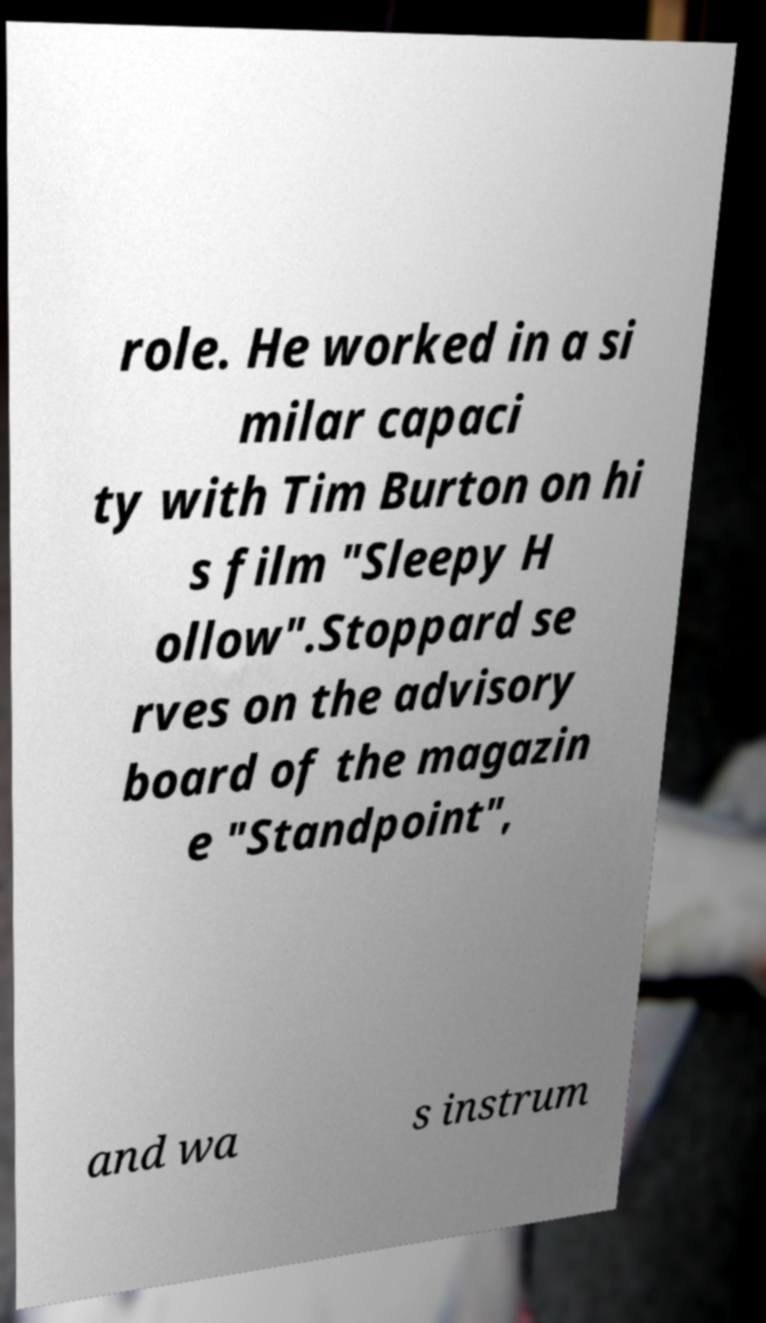What messages or text are displayed in this image? I need them in a readable, typed format. role. He worked in a si milar capaci ty with Tim Burton on hi s film "Sleepy H ollow".Stoppard se rves on the advisory board of the magazin e "Standpoint", and wa s instrum 